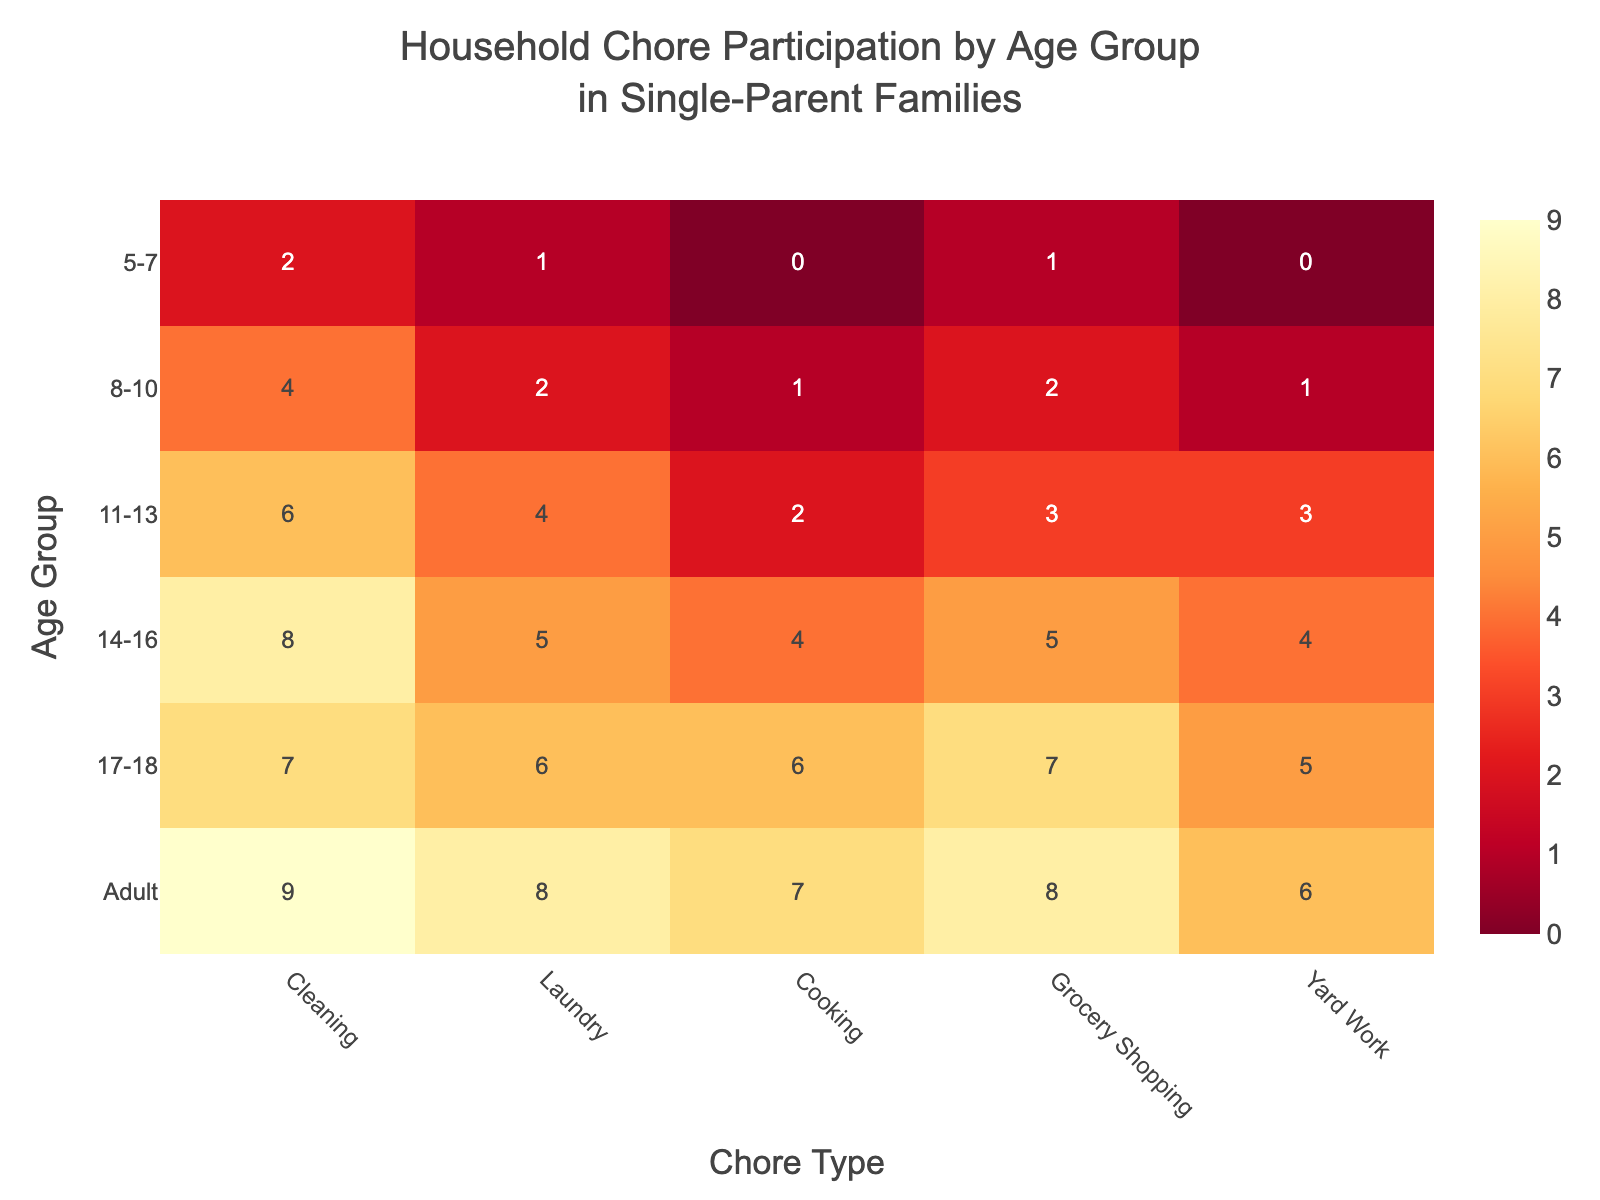What's the title of the figure? The title of the figure is located at the top, describing the context of the data. It typically provides a concise description.
Answer: Household Chore Participation by Age Group in Single-Parent Families Which age group participates the most in cooking? By scanning the cooking column, locate the age group with the highest value.
Answer: 17-18 How many chores do 8-10-year-olds participate in, on average? Sum the number of chores for the 8-10 age group (4 + 2 + 1 + 2 + 1) = 10, then divide by the number of chores (5).
Answer: 2 Which age group has a higher participation in yard work, 14-16 or 17-18? Compare the yard work values for 14-16 (4) and 17-18 (5).
Answer: 17-18 What is the difference in household chore participation in laundry between ages 11-13 and 17-18? Compare the values for laundry for 11-13 (4) and 17-18 (6); the difference is calculated by 6 - 4.
Answer: 2 Which age group shows a decrease in cleaning participation compared to the previous age group? Compare the cleaning values for each consecutive age group; 17-18 (7) shows a decrease compared to 14-16 (8).
Answer: 17-18 What's the maximum value for any chore type in the heatmap? Look across all values in the heatmap and identify the highest number.
Answer: 9 Which chore type shows the most even distribution of participation across all age groups? Assess the variation in numbers for each chore. Cooking ranges from 0 to 7, showing a relatively even distribution.
Answer: Cooking How does household chore participation in grocery shopping change as kids grow older? Follow the grocery shopping column; observe how values increase from young age groups to older age groups.
Answer: Increasing How many age groups have a participation score of 6 or higher in at least one chore? Count the number of age groups with any values of 6 or higher in any column.
Answer: 4 